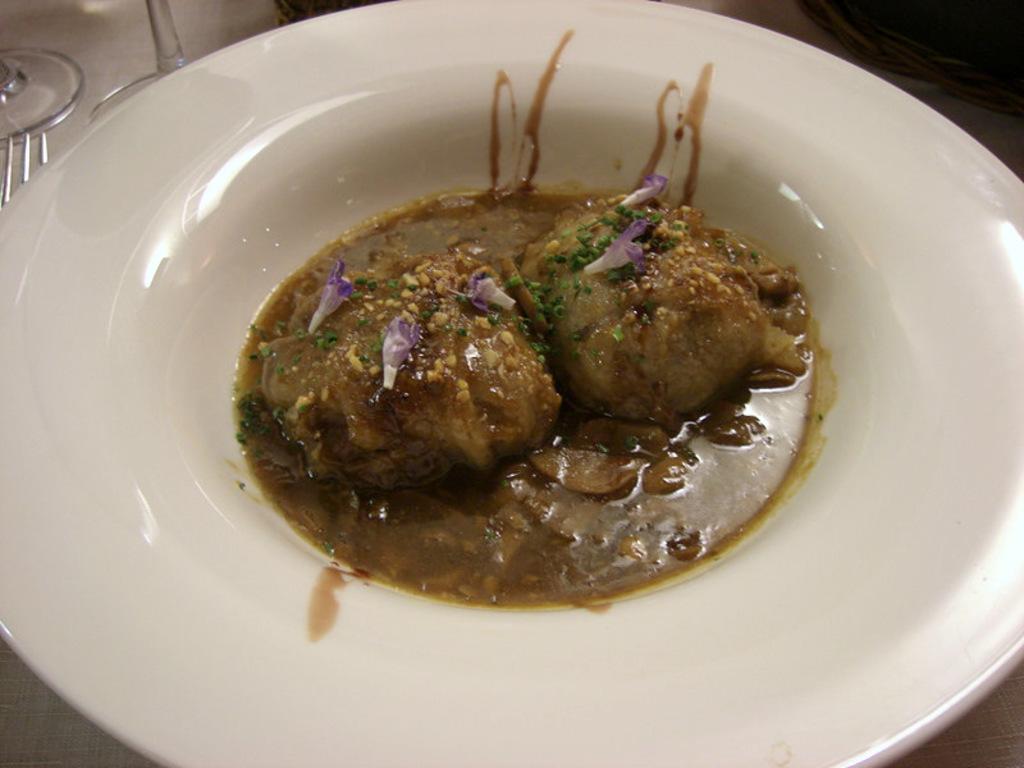In one or two sentences, can you explain what this image depicts? In this picture we can see food in the plate, in the background we can find glasses and a fork. 